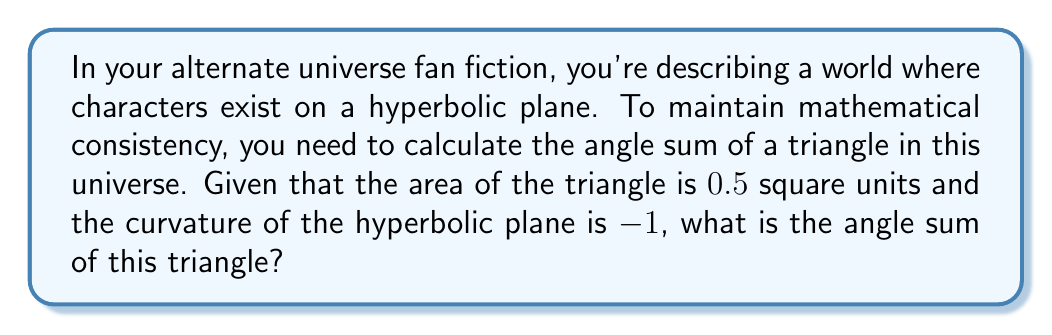Can you solve this math problem? Let's approach this step-by-step:

1) In hyperbolic geometry, the angle sum of a triangle is less than 180°. The difference between 180° and the actual angle sum is related to the area of the triangle and the curvature of the plane.

2) The formula for the angle sum of a triangle on a hyperbolic plane is:

   $$\alpha + \beta + \gamma = \pi - |K|A$$

   Where:
   - $\alpha$, $\beta$, and $\gamma$ are the angles of the triangle
   - $\pi$ is equal to 180° in radians
   - $K$ is the Gaussian curvature of the plane
   - $A$ is the area of the triangle

3) We're given that:
   - The area $A = 0.5$ square units
   - The curvature $K = -1$

4) Substituting these values into our formula:

   $$\alpha + \beta + \gamma = \pi - |-1| \cdot 0.5$$

5) Simplify:
   $$\alpha + \beta + \gamma = \pi - 0.5$$

6) Convert $\pi$ to degrees:
   $$\alpha + \beta + \gamma = 180° - \frac{180°}{\pi} \cdot 0.5$$

7) Calculate:
   $$\alpha + \beta + \gamma \approx 180° - 28.6479°$$
   $$\alpha + \beta + \gamma \approx 151.3521°$$

Thus, the angle sum of the triangle in your hyperbolic universe is approximately 151.3521°.
Answer: $151.3521°$ 